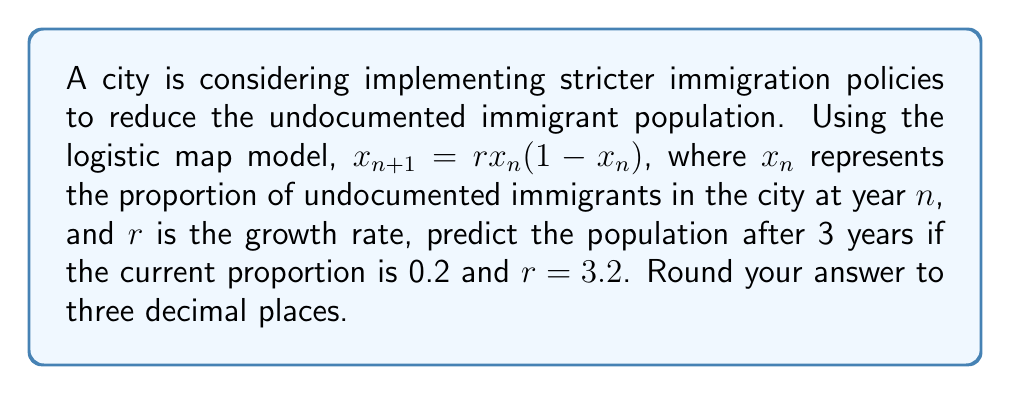Teach me how to tackle this problem. To solve this problem, we'll use the logistic map equation iteratively for 3 years:

1. Initial condition: $x_0 = 0.2$
2. Growth rate: $r = 3.2$

Year 1:
$$x_1 = r \cdot x_0 \cdot (1 - x_0)$$
$$x_1 = 3.2 \cdot 0.2 \cdot (1 - 0.2)$$
$$x_1 = 3.2 \cdot 0.2 \cdot 0.8 = 0.512$$

Year 2:
$$x_2 = r \cdot x_1 \cdot (1 - x_1)$$
$$x_2 = 3.2 \cdot 0.512 \cdot (1 - 0.512)$$
$$x_2 = 3.2 \cdot 0.512 \cdot 0.488 = 0.799744$$

Year 3:
$$x_3 = r \cdot x_2 \cdot (1 - x_2)$$
$$x_3 = 3.2 \cdot 0.799744 \cdot (1 - 0.799744)$$
$$x_3 = 3.2 \cdot 0.799744 \cdot 0.200256 = 0.513$$

Rounding to three decimal places: 0.513
Answer: 0.513 